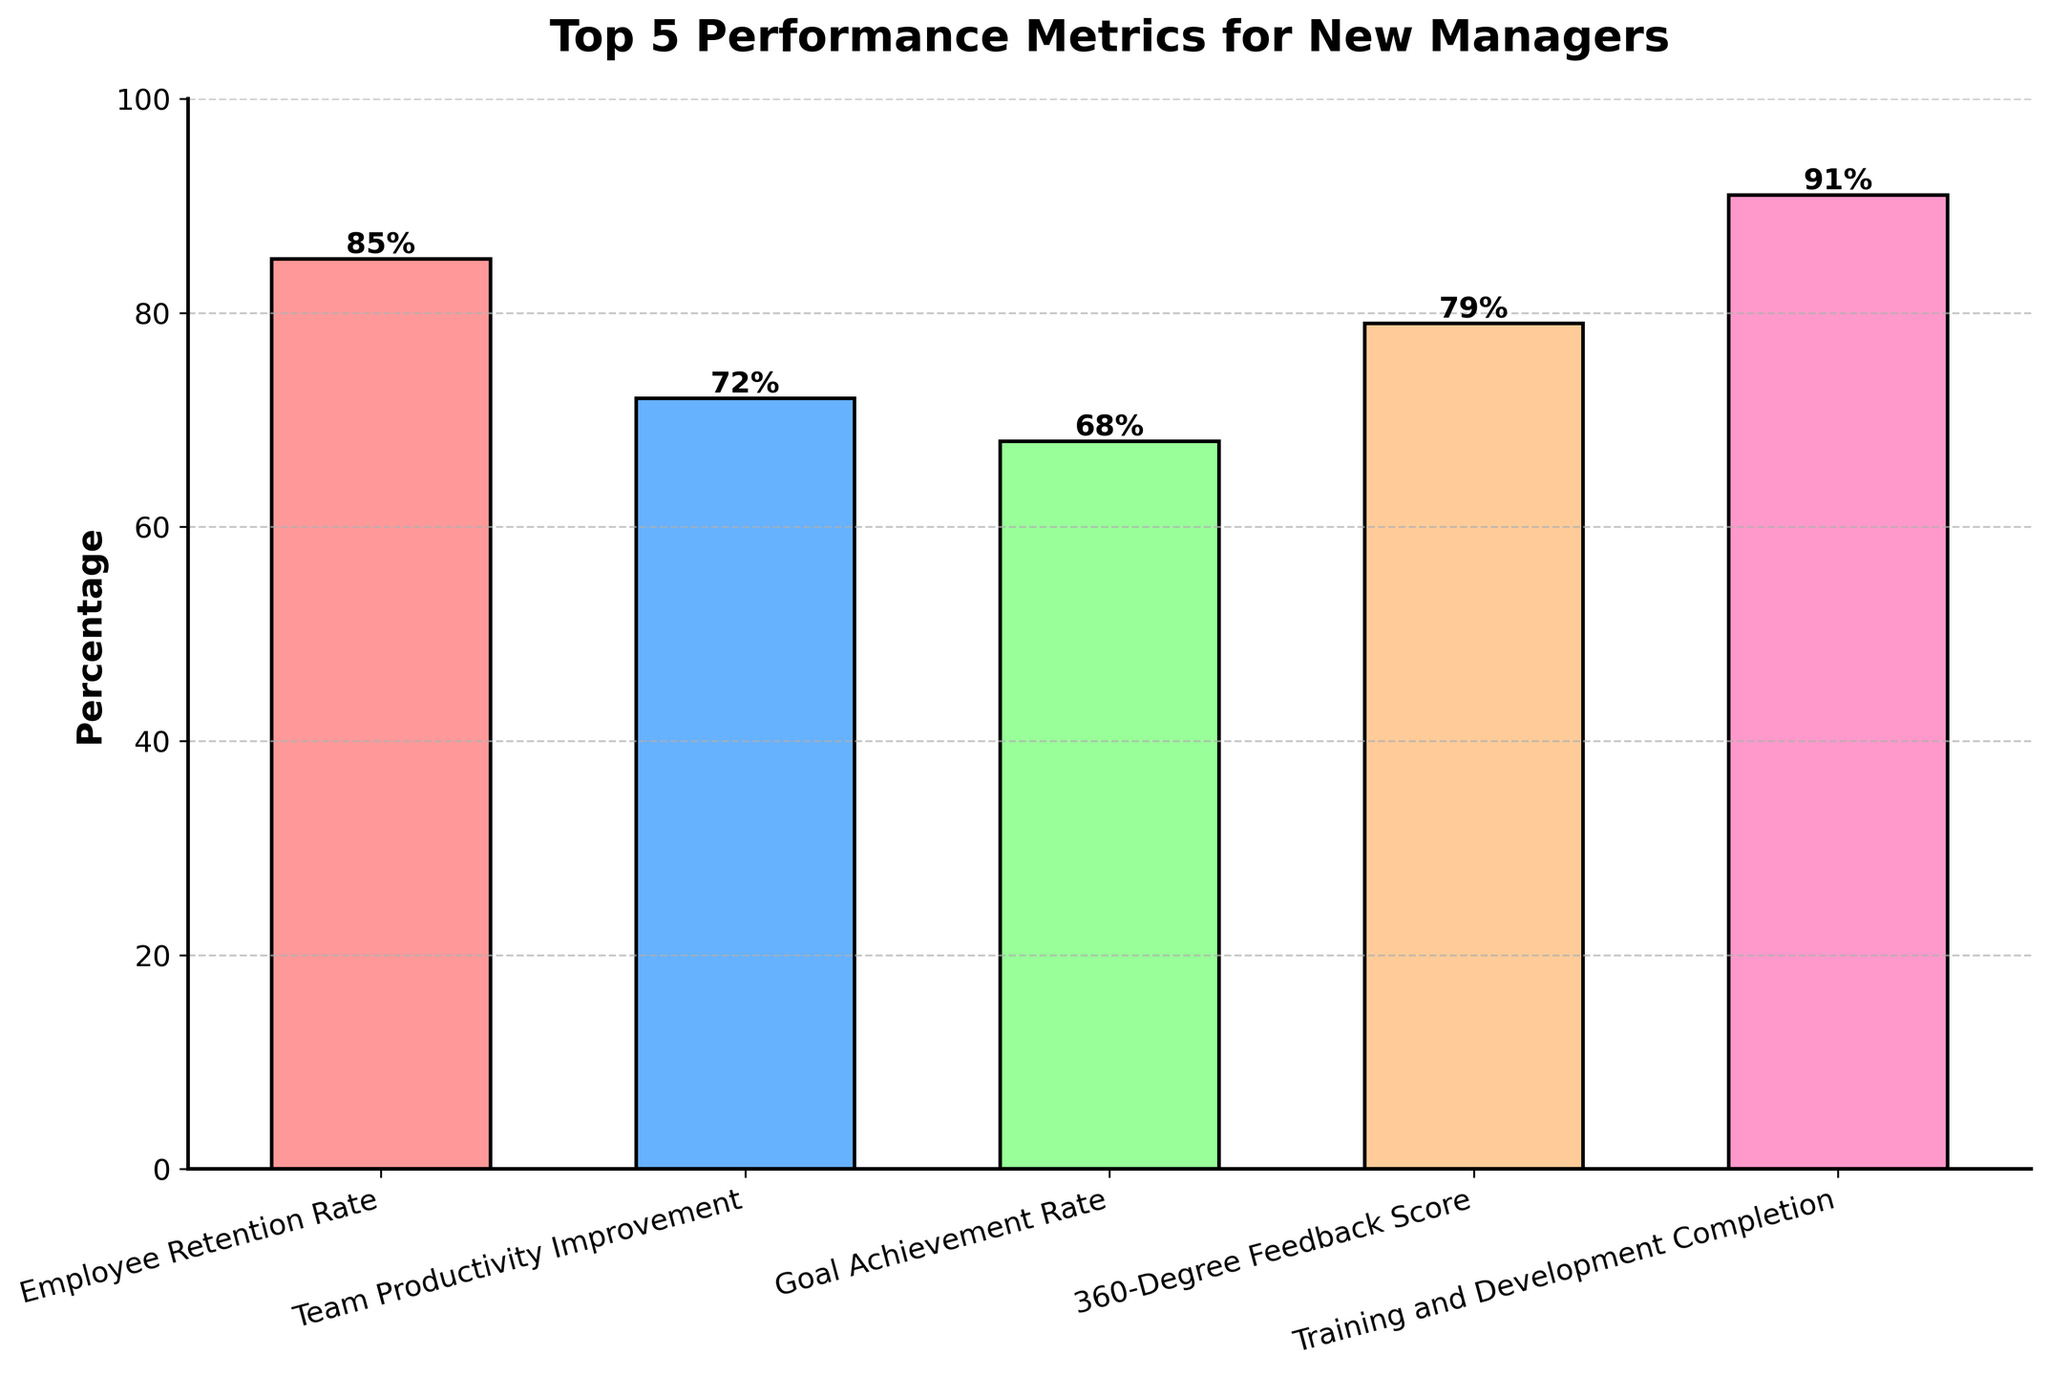What metric has the highest percentage? The metric with the highest percentage can be identified by looking for the tallest bar in the chart. 'Training and Development Completion' is the tallest bar with 91%.
Answer: Training and Development Completion Which metric shows the lowest percentage? The metric with the lowest percentage can be identified by finding the shortest bar in the chart. 'Goal Achievement Rate' is the shortest bar with 68%.
Answer: Goal Achievement Rate How many metrics have a percentage greater than 70%? Count the bars that have a height greater than 70%. The bars for 'Employee Retention Rate', 'Team Productivity Improvement', '360-Degree Feedback Score', and 'Training and Development Completion' are all above 70%. That makes 4 metrics.
Answer: 4 Which metric has a percentage closest to 75%? Look for the bar whose height is nearest to 75%. 'Team Productivity Improvement' at 72% is closest to 75%.
Answer: Team Productivity Improvement By how much does the percentage of 'Employee Retention Rate' exceed 'Goal Achievement Rate'? Subtract the percentage of 'Goal Achievement Rate' from 'Employee Retention Rate'. 85% - 68% = 17%.
Answer: 17% What is the average percentage of all the metrics? Sum all the percentages and divide by the number of metrics: (85 + 72 + 68 + 79 + 91) / 5 = 79%.
Answer: 79% Is '360-Degree Feedback Score' greater than 'Team Productivity Improvement'? By how much? Compare their percentages. '360-Degree Feedback Score' (79%) is greater than 'Team Productivity Improvement' (72%) by 79% - 72% = 7%.
Answer: Yes, by 7% Which metric falls between 'Team Productivity Improvement' and 'Training and Development Completion' in terms of percentage? Identify which bar falls between 'Team Productivity Improvement' (72%) and 'Training and Development Completion' (91%) in height. '360-Degree Feedback Score' at 79% fits this criterion.
Answer: 360-Degree Feedback Score What is the difference between the highest and lowest percentages? Subtract the lowest percentage from the highest percentage. 91% (Training and Development Completion) - 68% (Goal Achievement Rate) = 23%.
Answer: 23% 